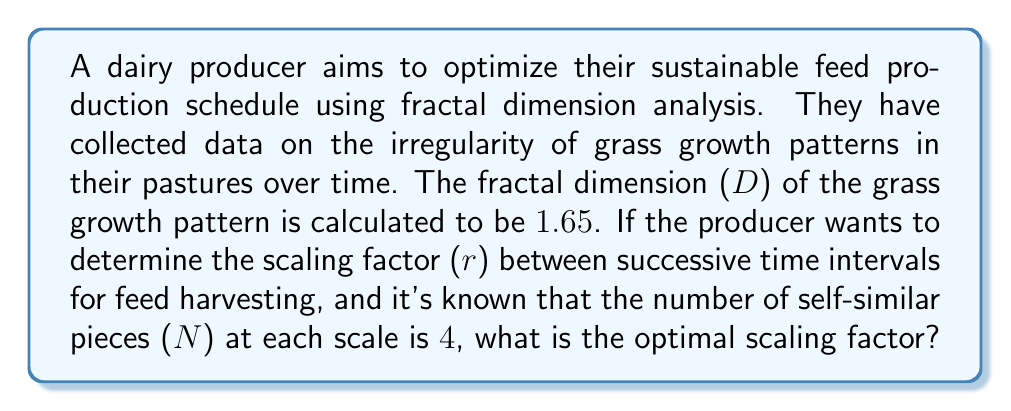Give your solution to this math problem. To solve this problem, we'll use the fundamental equation of fractal dimension:

$$D = \frac{\log N}{\log(\frac{1}{r})}$$

Where:
D = Fractal dimension
N = Number of self-similar pieces
r = Scaling factor

We are given:
D = 1.65
N = 4

Step 1: Substitute the known values into the equation:

$$1.65 = \frac{\log 4}{\log(\frac{1}{r})}$$

Step 2: Simplify the numerator:

$$1.65 = \frac{2\log 2}{\log(\frac{1}{r})}$$

Step 3: Multiply both sides by $\log(\frac{1}{r})$:

$$1.65 \log(\frac{1}{r}) = 2\log 2$$

Step 4: Divide both sides by 1.65:

$$\log(\frac{1}{r}) = \frac{2\log 2}{1.65}$$

Step 5: Apply the exponential function to both sides:

$$\frac{1}{r} = e^{\frac{2\log 2}{1.65}}$$

Step 6: Take the reciprocal of both sides:

$$r = e^{-\frac{2\log 2}{1.65}}$$

Step 7: Calculate the final value:

$$r \approx 0.6309$$

This scaling factor suggests that each successive time interval for feed harvesting should be approximately 63.09% of the previous interval, optimizing the sustainable feed production schedule based on the fractal dimension analysis of grass growth patterns.
Answer: $r \approx 0.6309$ 